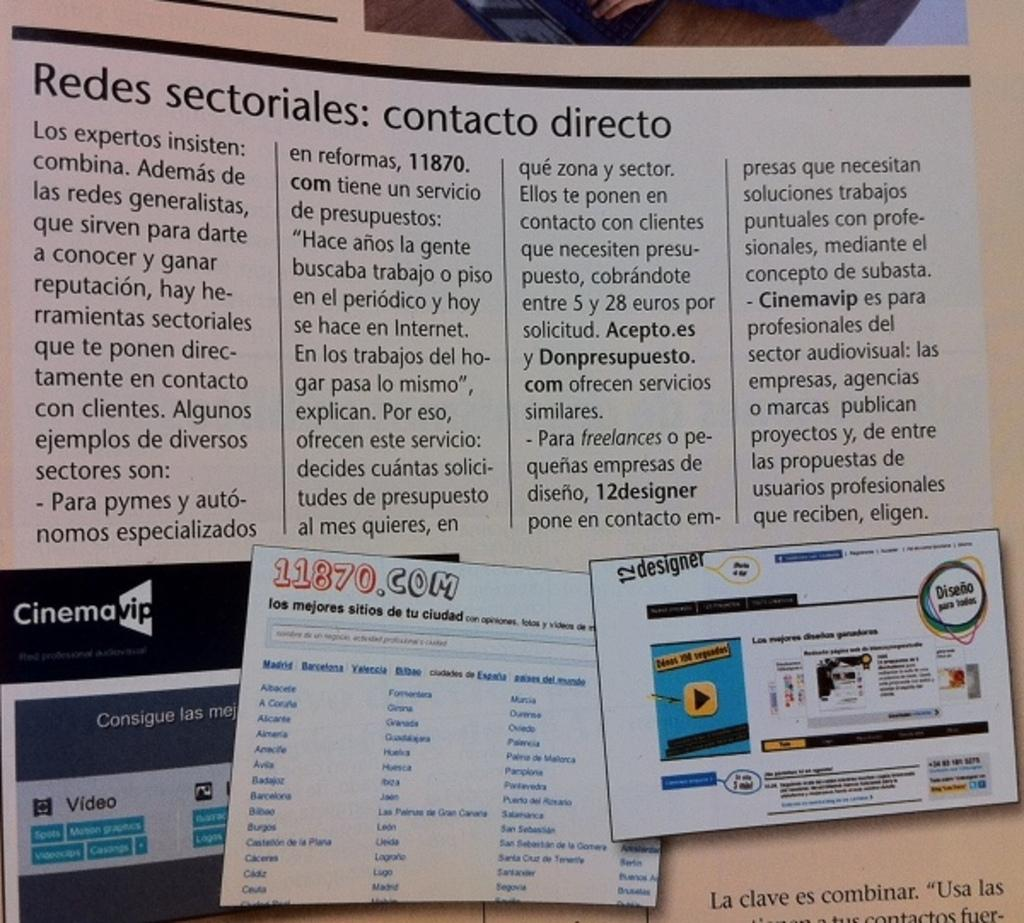<image>
Provide a brief description of the given image. A contact section written out in Spanish with a few screenshots 